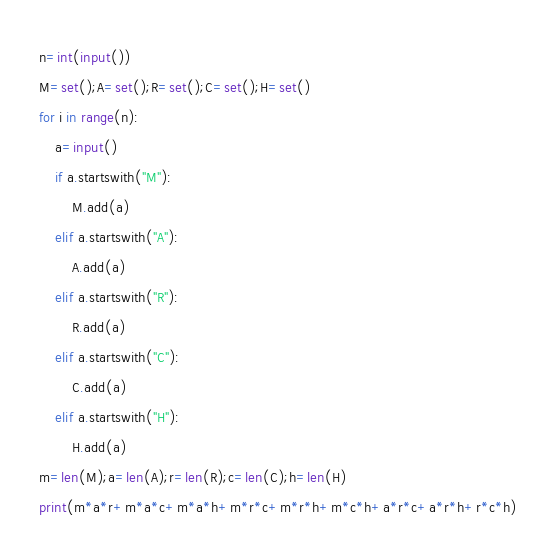Convert code to text. <code><loc_0><loc_0><loc_500><loc_500><_Python_>n=int(input())
M=set();A=set();R=set();C=set();H=set()
for i in range(n):
    a=input()
    if a.startswith("M"):
        M.add(a)
    elif a.startswith("A"):
        A.add(a)
    elif a.startswith("R"):
        R.add(a)
    elif a.startswith("C"):
        C.add(a)
    elif a.startswith("H"):
        H.add(a)
m=len(M);a=len(A);r=len(R);c=len(C);h=len(H)
print(m*a*r+m*a*c+m*a*h+m*r*c+m*r*h+m*c*h+a*r*c+a*r*h+r*c*h)</code> 